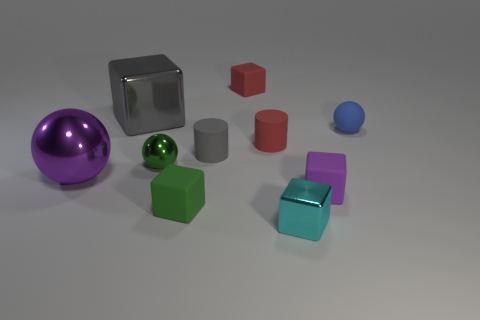Subtract all metallic spheres. How many spheres are left? 1 Subtract 5 cubes. How many cubes are left? 0 Subtract all blue balls. How many balls are left? 2 Subtract all yellow balls. How many red blocks are left? 1 Add 6 purple objects. How many purple objects are left? 8 Add 1 large blocks. How many large blocks exist? 2 Subtract 0 gray balls. How many objects are left? 10 Subtract all balls. How many objects are left? 7 Subtract all yellow spheres. Subtract all gray cylinders. How many spheres are left? 3 Subtract all purple cubes. Subtract all tiny blue blocks. How many objects are left? 9 